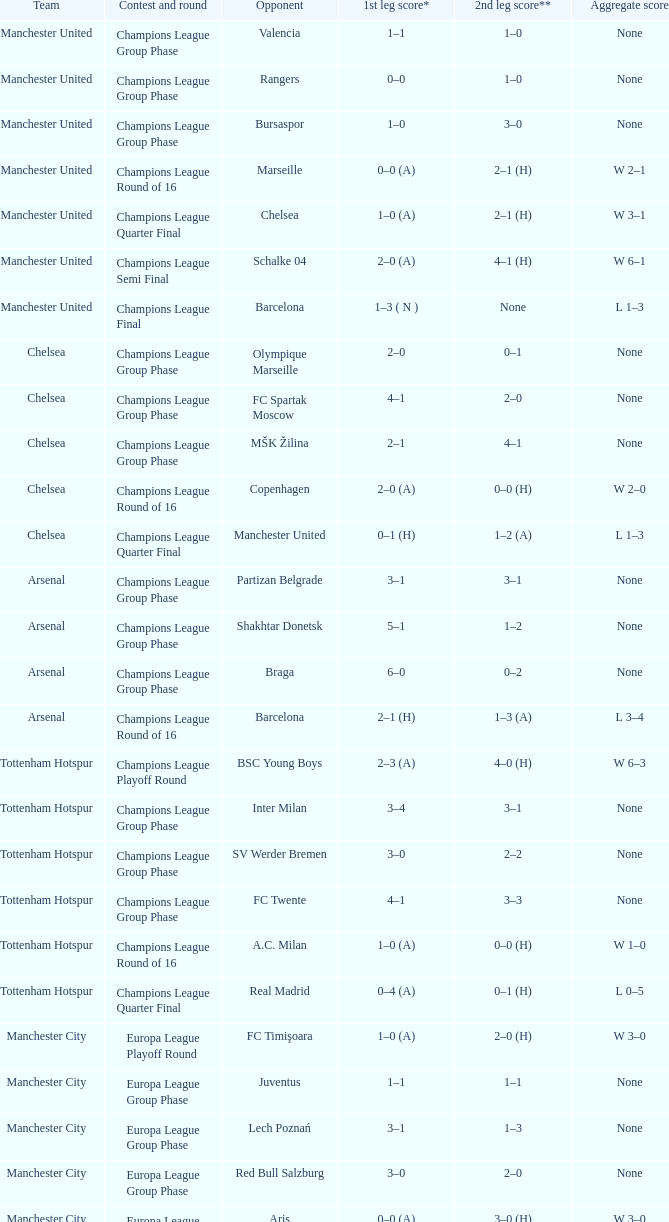In the opening leg of the match between liverpool and steaua bucureşti, how many goals were scored by each team? 4–1. 